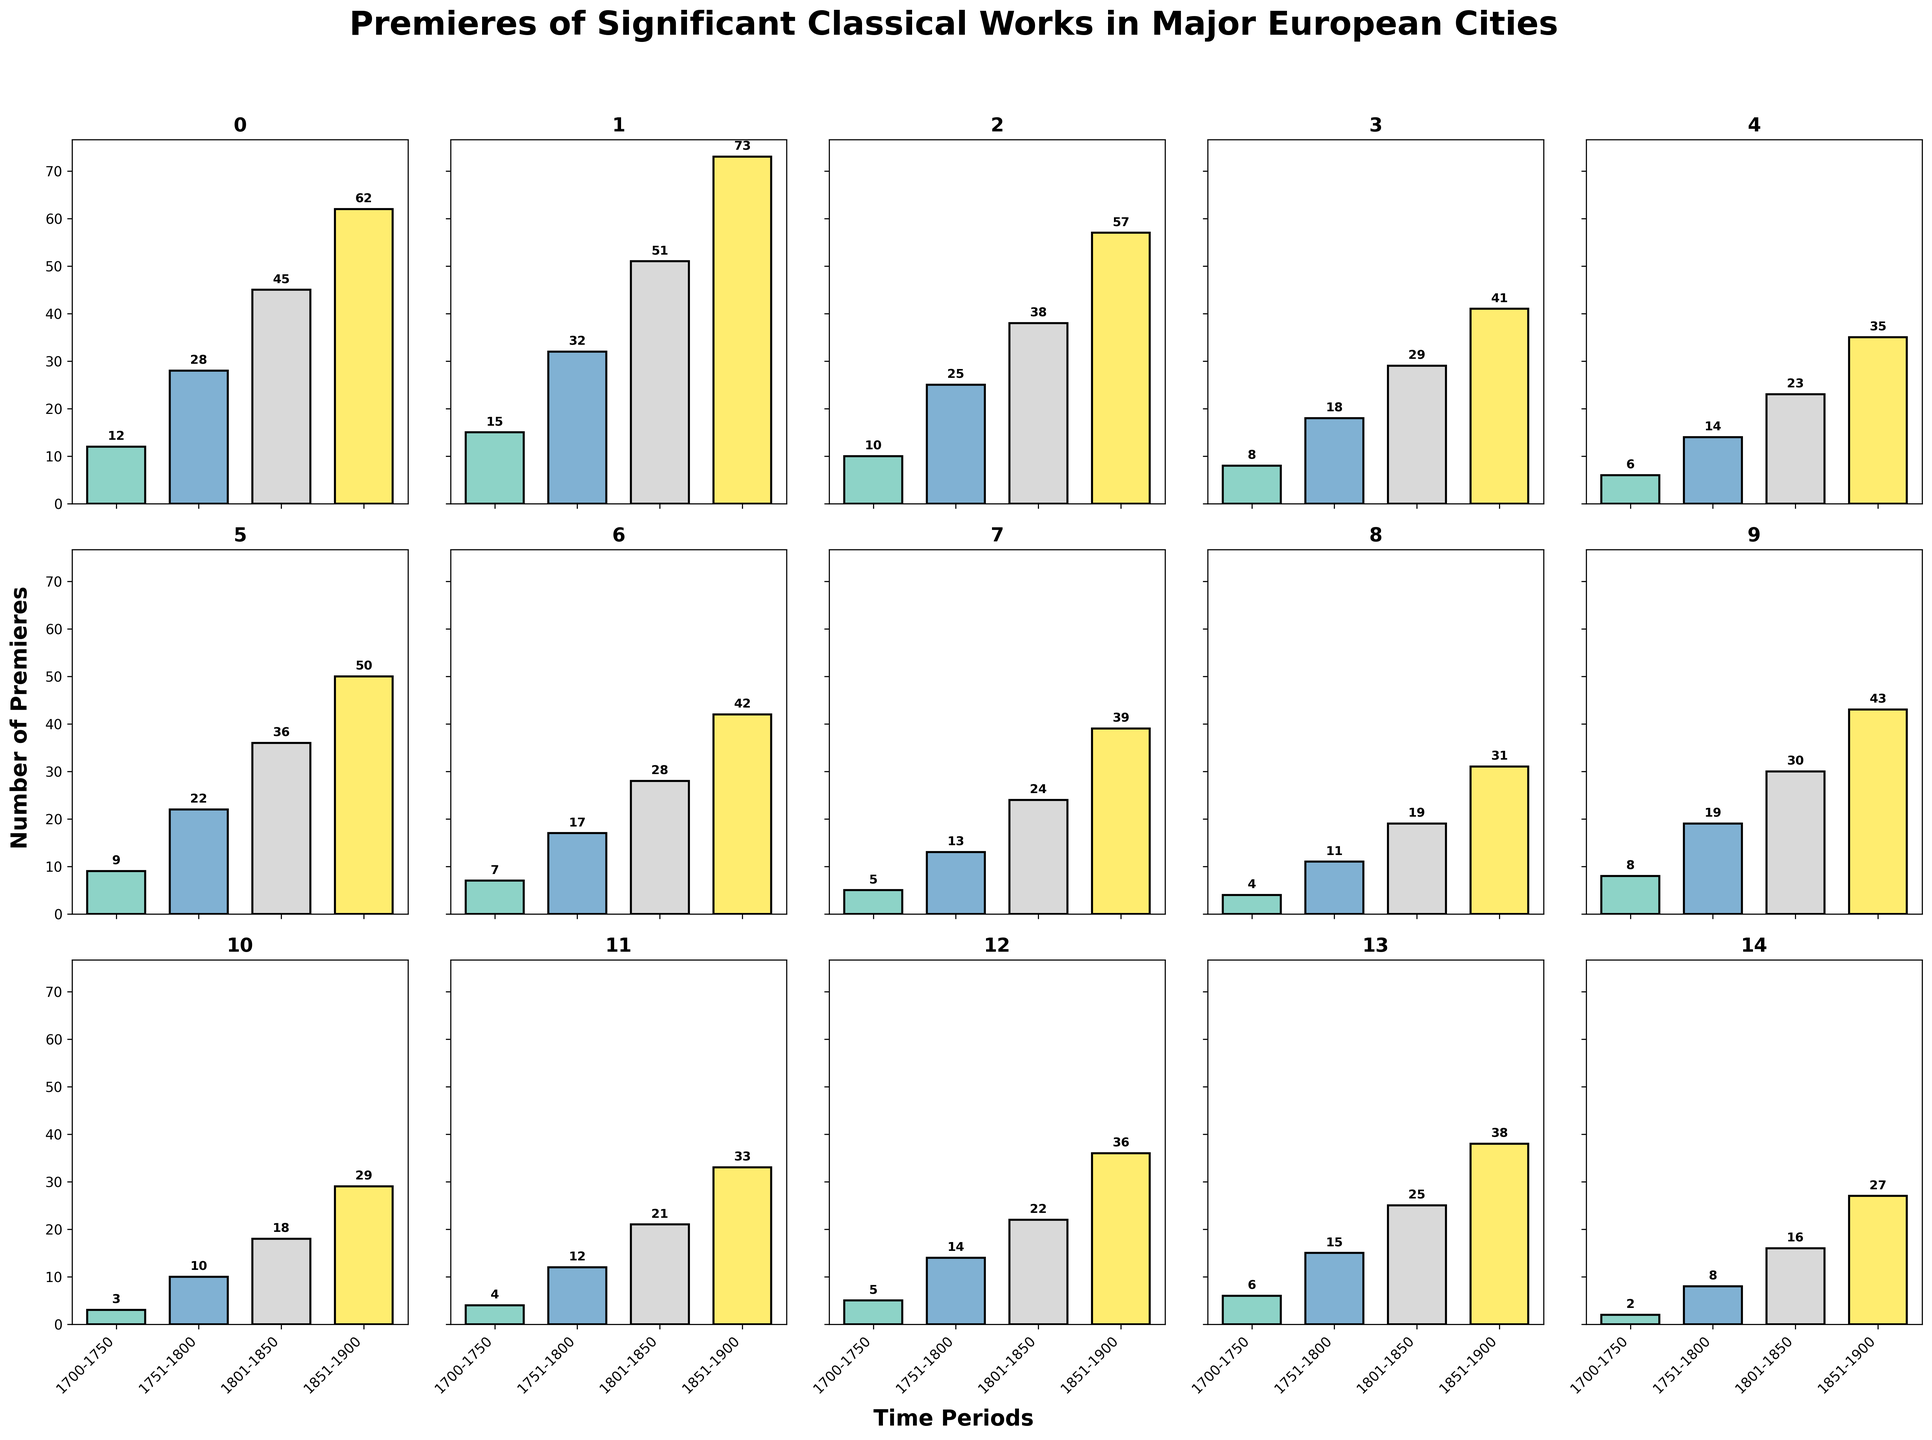Which city had the highest number of premieres in 1851-1900? Look at the bars corresponding to "1851-1900" for all cities, compare their heights and annotations. Paris has the highest bar and annotation of 73.
Answer: Paris What is the total number of premieres in Milan across all periods? Add the numbers of Milan premieres from all periods: 9 (1700-1750) + 22 (1751-1800) + 36 (1801-1850) + 50 (1851-1900). The sum is 117.
Answer: 117 Which city showed the least growth in the number of premieres from 1700-1750 to 1851-1900? Calculate the difference between the 1700-1750 and 1851-1900 numbers for each city and compare them. Warsaw had the smallest increase, from 2 to 27, which is 25.
Answer: Warsaw How many premieres were held in Vienna and Leipzig combined in the period 1801-1850? Add the number of premieres for Vienna and Leipzig in the period 1801-1850: 45 (Vienna) + 29 (Leipzig). The total is 74.
Answer: 74 Which city had the most premieres in the period 1751-1800? Compare the heights and annotations of the bars for the period 1751-1800. Paris has the highest annotation of 32.
Answer: Paris What is the average number of premieres per city in the period 1700-1750? Add the numbers for all cities in the period 1700-1750 and divide by the number of cities. Total is 104, divide by 15 gives approximately 6.93.
Answer: ~6.93 In which period did Berlin see the greatest increase in premieres compared to the previous period? Calculate the differences between periods for Berlin: (1851-1900: 39 - 1801-1850: 24 = 15), (1801-1850: 24 - 1751-1800: 13 = 11), (1751-1800: 13 - 1700-1750: 5 = 8). The greatest increase is 15 in 1851-1900.
Answer: 1851-1900 Which city had exactly 28 premieres in 1801-1850? Check the annotations for each city in 1801-1850 for a match of 28. Rome had 28 premieres.
Answer: Rome How many more premieres were there in Paris in 1851-1900 compared to London in the same period? Subtract London's 57 premieres in 1851-1900 from Paris's 73. The difference is 16.
Answer: 16 